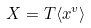Convert formula to latex. <formula><loc_0><loc_0><loc_500><loc_500>X = T \langle x ^ { v } \rangle</formula> 